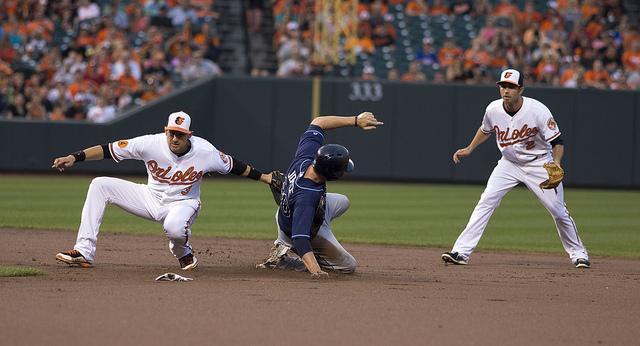How many players are playing?
Give a very brief answer. 3. How many people are there?
Give a very brief answer. 4. 